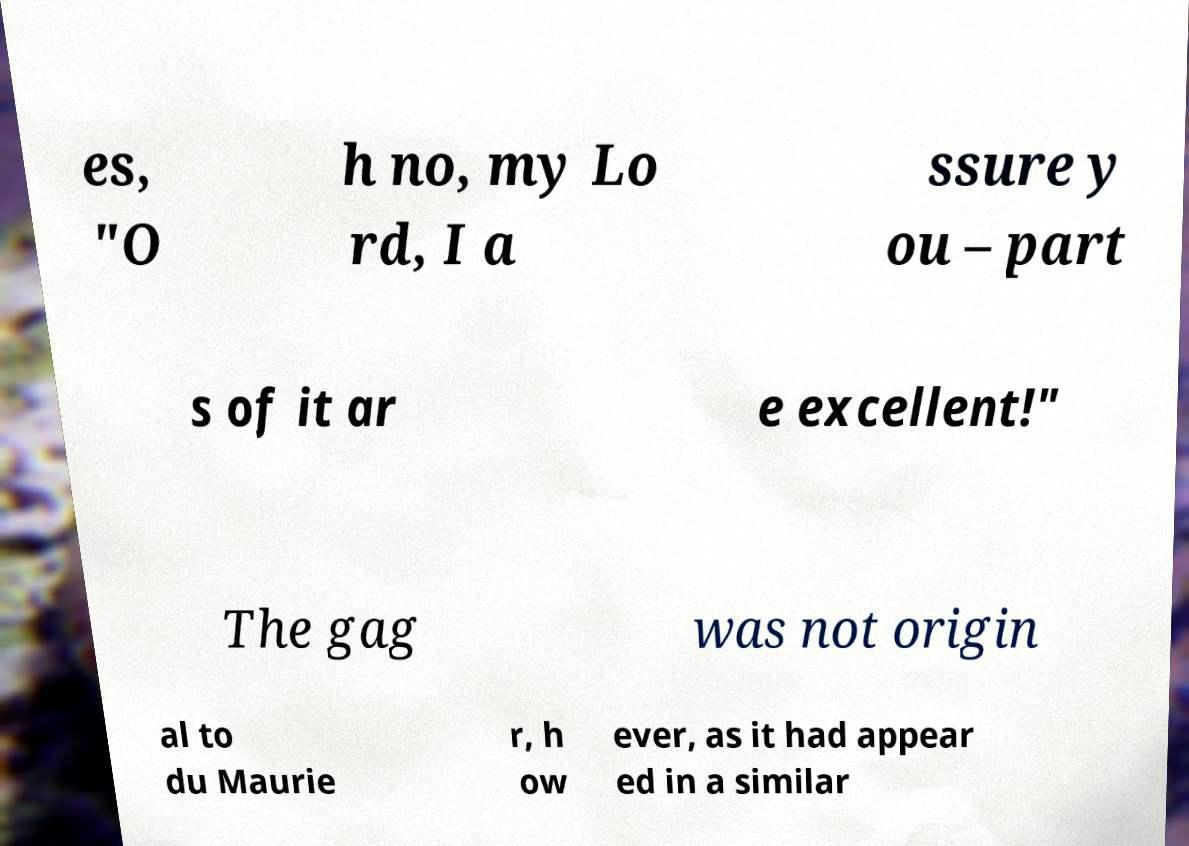Could you assist in decoding the text presented in this image and type it out clearly? es, "O h no, my Lo rd, I a ssure y ou – part s of it ar e excellent!" The gag was not origin al to du Maurie r, h ow ever, as it had appear ed in a similar 